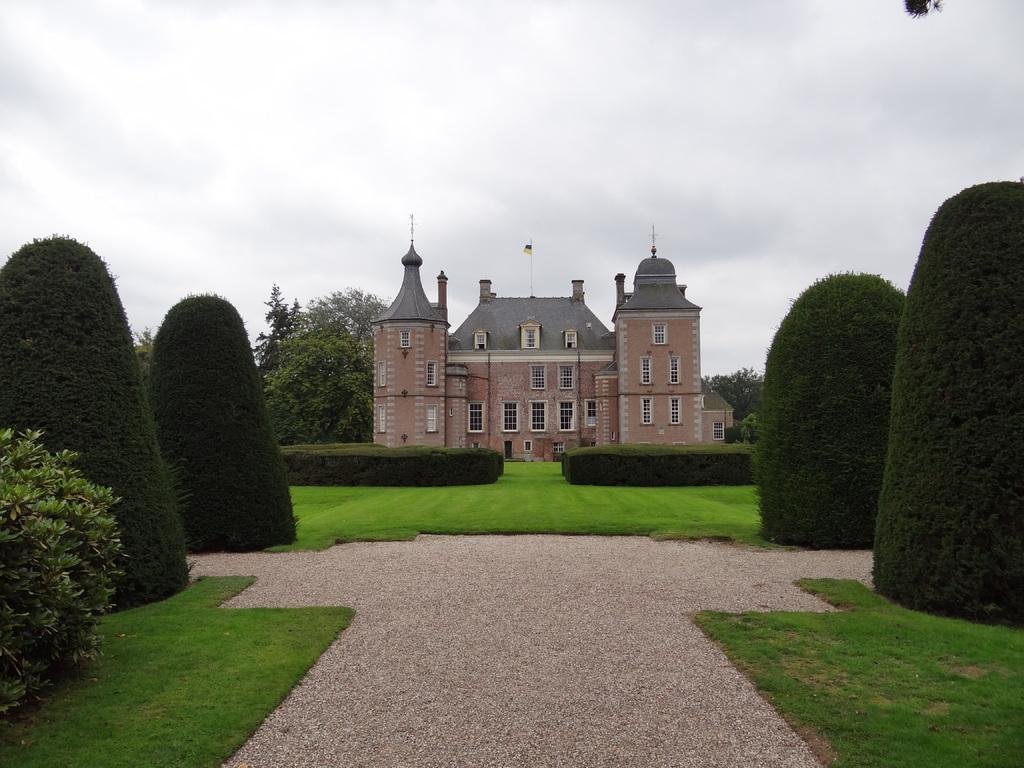What is the main subject in the middle of the image? There is a house in the middle of the image. What type of vegetation can be seen in the image? There are trees in the image. How would you describe the sky in the image? The sky is cloudy in the image. What route does the porter take to deliver packages to the house in the image? There is no porter present in the image, so it is not possible to determine the route they might take. 